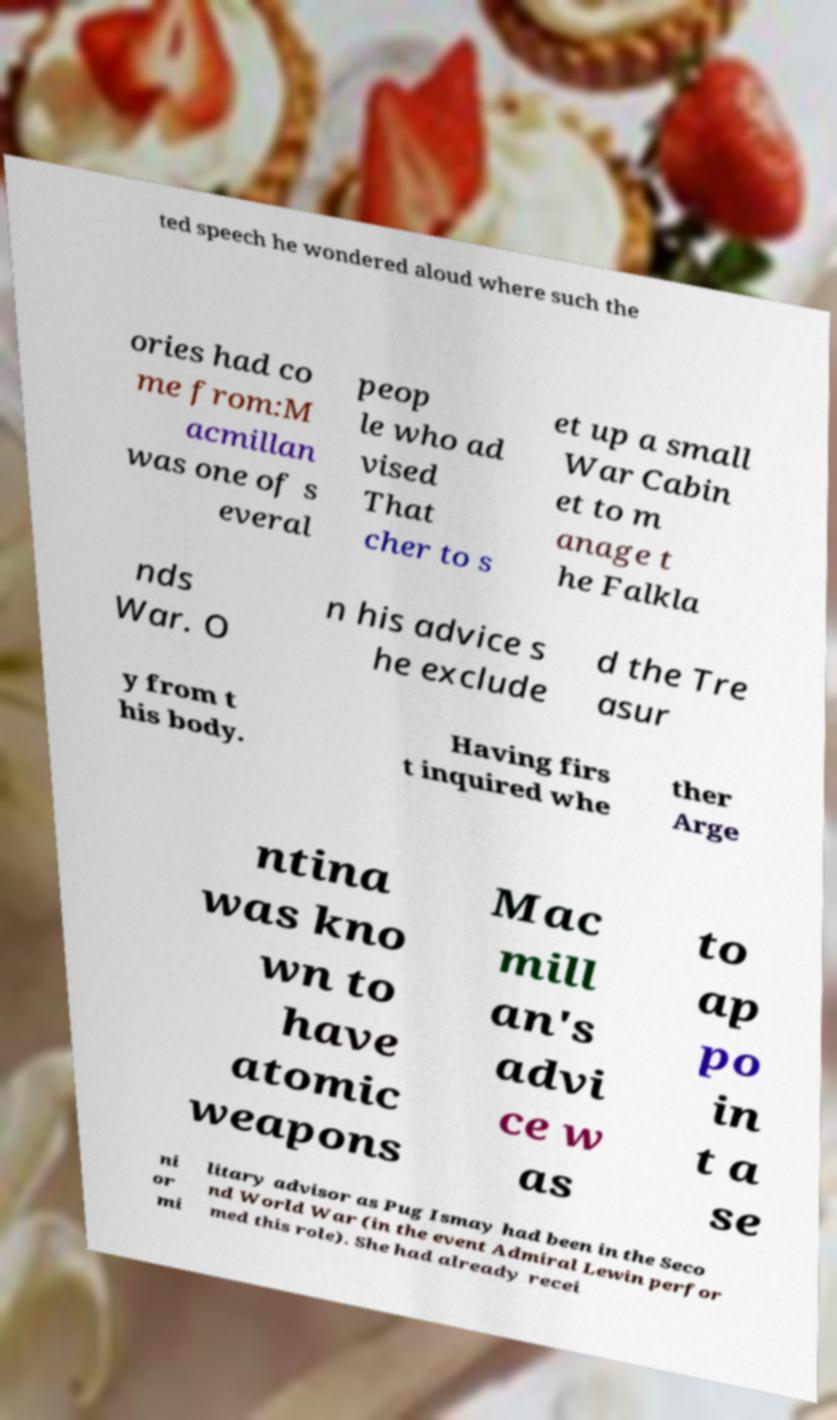I need the written content from this picture converted into text. Can you do that? ted speech he wondered aloud where such the ories had co me from:M acmillan was one of s everal peop le who ad vised That cher to s et up a small War Cabin et to m anage t he Falkla nds War. O n his advice s he exclude d the Tre asur y from t his body. Having firs t inquired whe ther Arge ntina was kno wn to have atomic weapons Mac mill an's advi ce w as to ap po in t a se ni or mi litary advisor as Pug Ismay had been in the Seco nd World War (in the event Admiral Lewin perfor med this role). She had already recei 